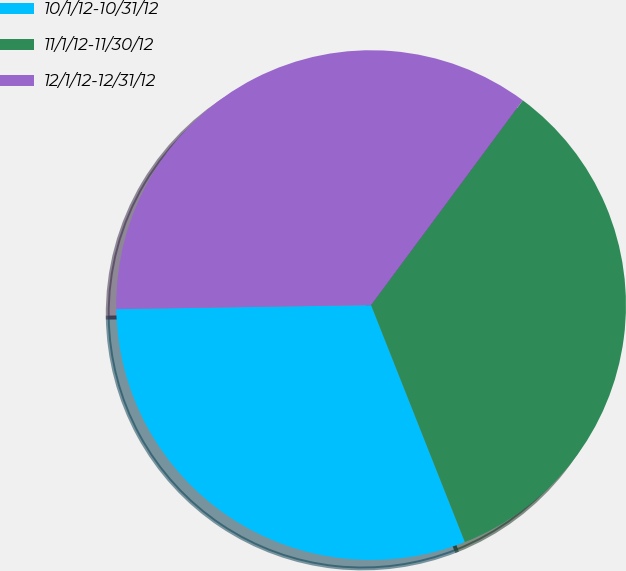<chart> <loc_0><loc_0><loc_500><loc_500><pie_chart><fcel>10/1/12-10/31/12<fcel>11/1/12-11/30/12<fcel>12/1/12-12/31/12<nl><fcel>30.75%<fcel>33.85%<fcel>35.4%<nl></chart> 